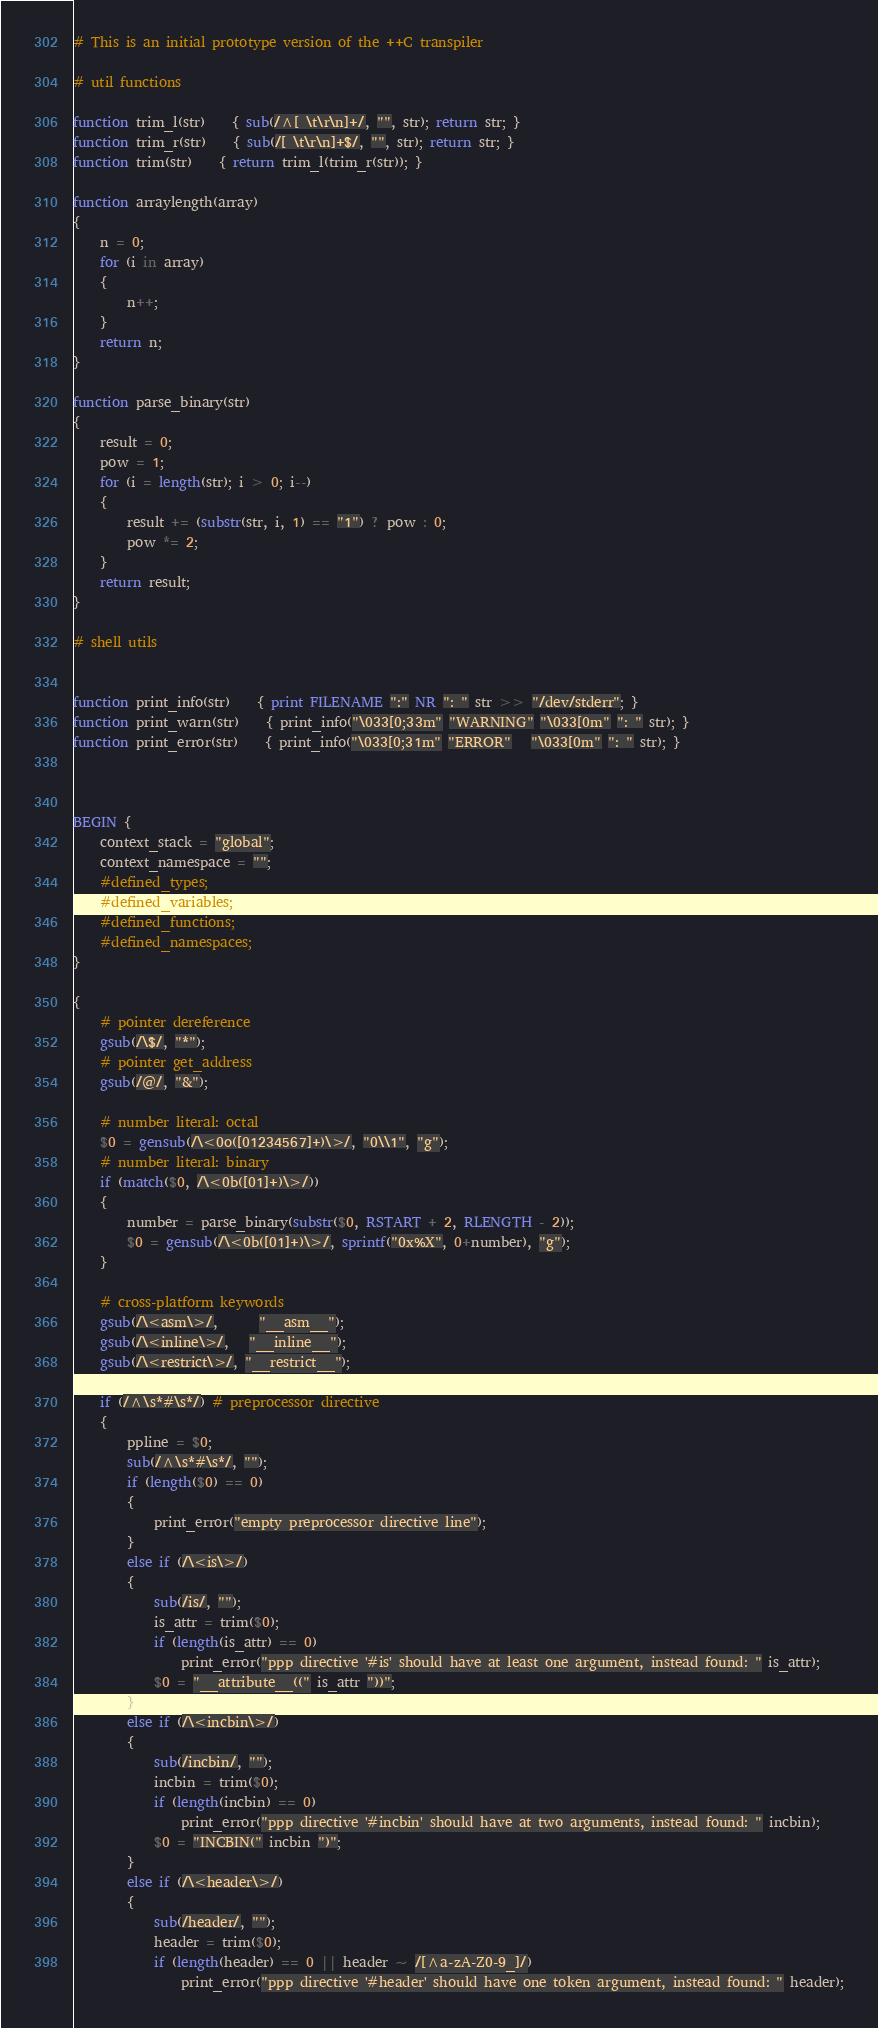Convert code to text. <code><loc_0><loc_0><loc_500><loc_500><_Awk_># This is an initial prototype version of the ++C transpiler

# util functions

function trim_l(str)	{ sub(/^[ \t\r\n]+/, "", str); return str; }
function trim_r(str)	{ sub(/[ \t\r\n]+$/, "", str); return str; }
function trim(str)	{ return trim_l(trim_r(str)); }

function arraylength(array)
{
	n = 0;
	for (i in array)
	{
		n++;
	}
	return n;
}

function parse_binary(str)
{
	result = 0;
	pow = 1;
	for (i = length(str); i > 0; i--)
	{
		result += (substr(str, i, 1) == "1") ? pow : 0;
		pow *= 2;
	}
	return result;
}

# shell utils


function print_info(str)	{ print FILENAME ":" NR ": " str >> "/dev/stderr"; }
function print_warn(str)	{ print_info("\033[0;33m" "WARNING" "\033[0m" ": " str); }
function print_error(str)	{ print_info("\033[0;31m" "ERROR"   "\033[0m" ": " str); }



BEGIN {
	context_stack = "global";
	context_namespace = "";
	#defined_types;
	#defined_variables;
	#defined_functions;
	#defined_namespaces;
}

{
	# pointer dereference
	gsub(/\$/, "*");
	# pointer get_address
	gsub(/@/, "&");

	# number literal: octal
	$0 = gensub(/\<0o([01234567]+)\>/, "0\\1", "g");
	# number literal: binary
	if (match($0, /\<0b([01]+)\>/))
	{
		number = parse_binary(substr($0, RSTART + 2, RLENGTH - 2));
		$0 = gensub(/\<0b([01]+)\>/, sprintf("0x%X", 0+number), "g");
	}

	# cross-platform keywords
	gsub(/\<asm\>/,      "__asm__");
	gsub(/\<inline\>/,   "__inline__");
	gsub(/\<restrict\>/, "__restrict__");

	if (/^\s*#\s*/) # preprocessor directive
	{
		ppline = $0;
		sub(/^\s*#\s*/, "");
		if (length($0) == 0)
		{
			print_error("empty preprocessor directive line");
		}
		else if (/\<is\>/)
		{
			sub(/is/, "");
			is_attr = trim($0);
			if (length(is_attr) == 0)
				print_error("ppp directive '#is' should have at least one argument, instead found: " is_attr);
			$0 = "__attribute__((" is_attr "))";
		}
		else if (/\<incbin\>/)
		{
			sub(/incbin/, "");
			incbin = trim($0);
			if (length(incbin) == 0)
				print_error("ppp directive '#incbin' should have at two arguments, instead found: " incbin);
			$0 = "INCBIN(" incbin ")";
		}
		else if (/\<header\>/)
		{
			sub(/header/, "");
			header = trim($0);
			if (length(header) == 0 || header ~ /[^a-zA-Z0-9_]/)
				print_error("ppp directive '#header' should have one token argument, instead found: " header);</code> 